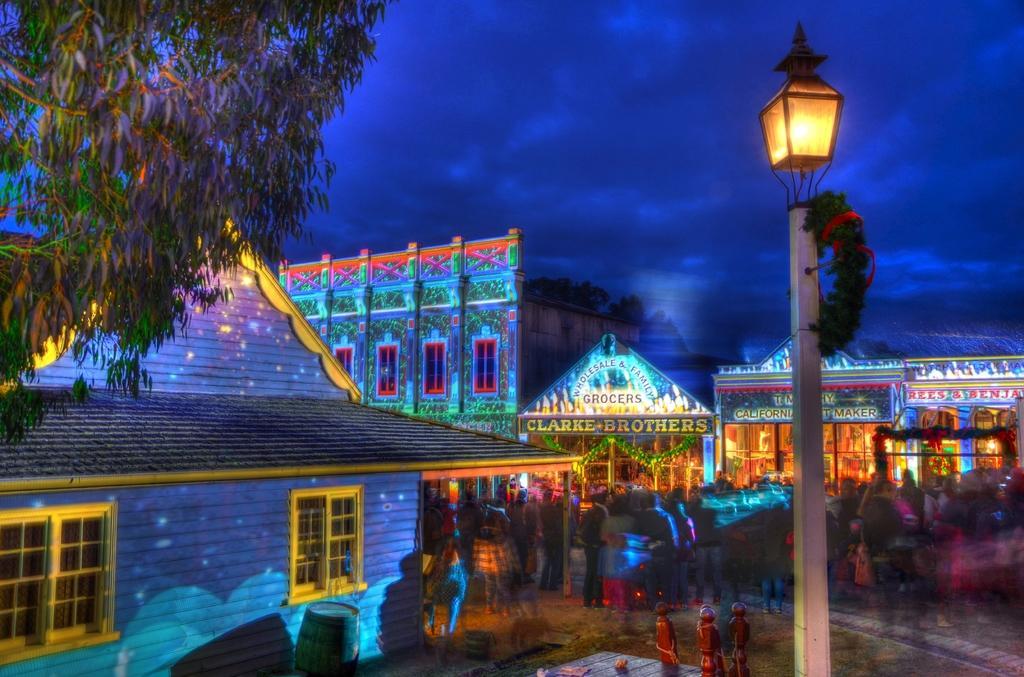Can you describe this image briefly? At the bottom of this image, there are persons, a light attached to a pole, buildings which are decorated with lighting and trees on the ground. In the background, there are clouds in the sky. 